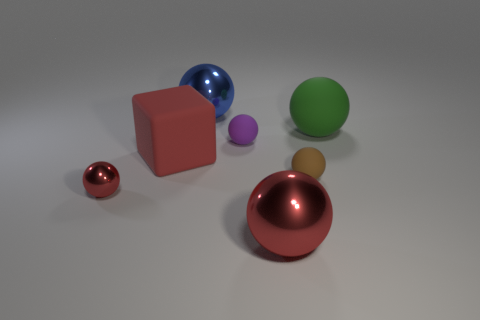Subtract 4 spheres. How many spheres are left? 2 Subtract all blue spheres. How many spheres are left? 5 Subtract all purple rubber balls. How many balls are left? 5 Subtract all blue spheres. Subtract all blue blocks. How many spheres are left? 5 Add 2 tiny gray cubes. How many objects exist? 9 Subtract all spheres. How many objects are left? 1 Subtract all tiny cyan shiny spheres. Subtract all blocks. How many objects are left? 6 Add 4 tiny metallic balls. How many tiny metallic balls are left? 5 Add 6 rubber balls. How many rubber balls exist? 9 Subtract 0 yellow cylinders. How many objects are left? 7 